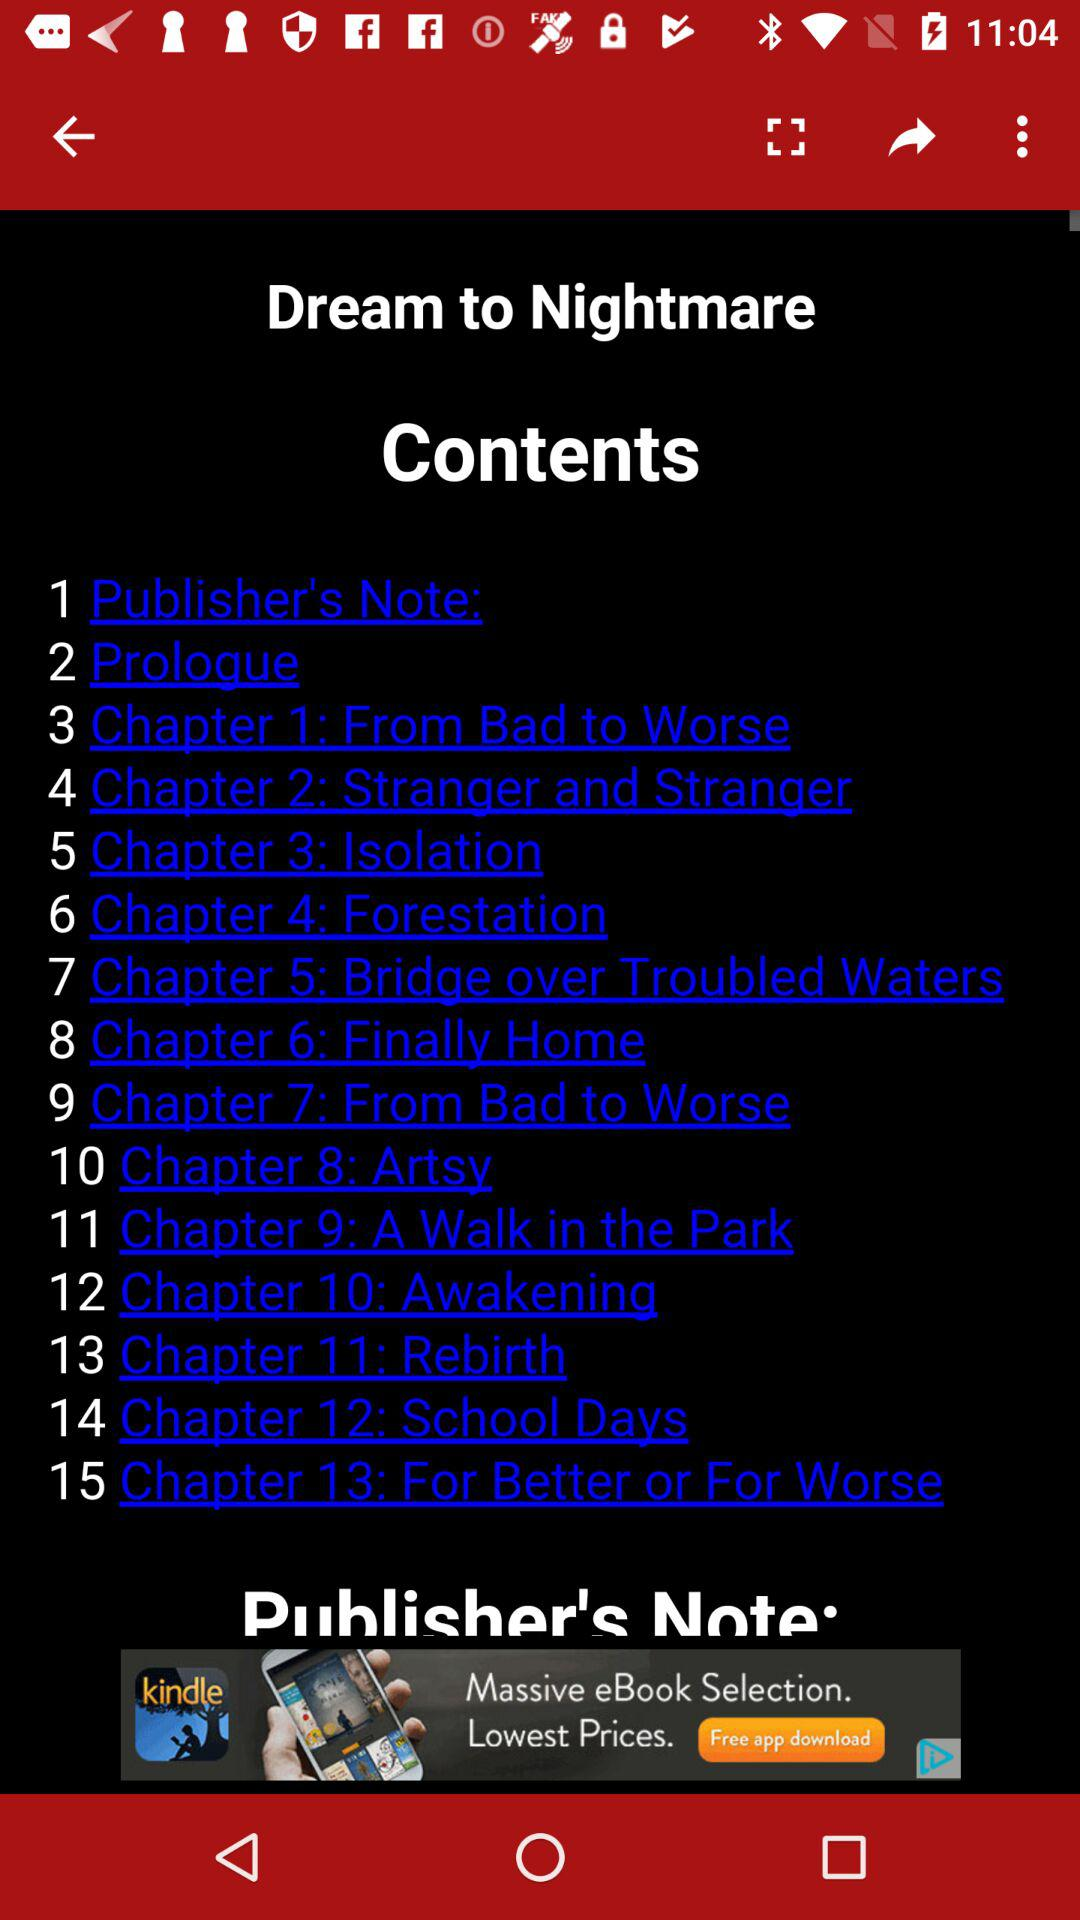What is Chapter 11? Chapter 12 is "Rebirth". 